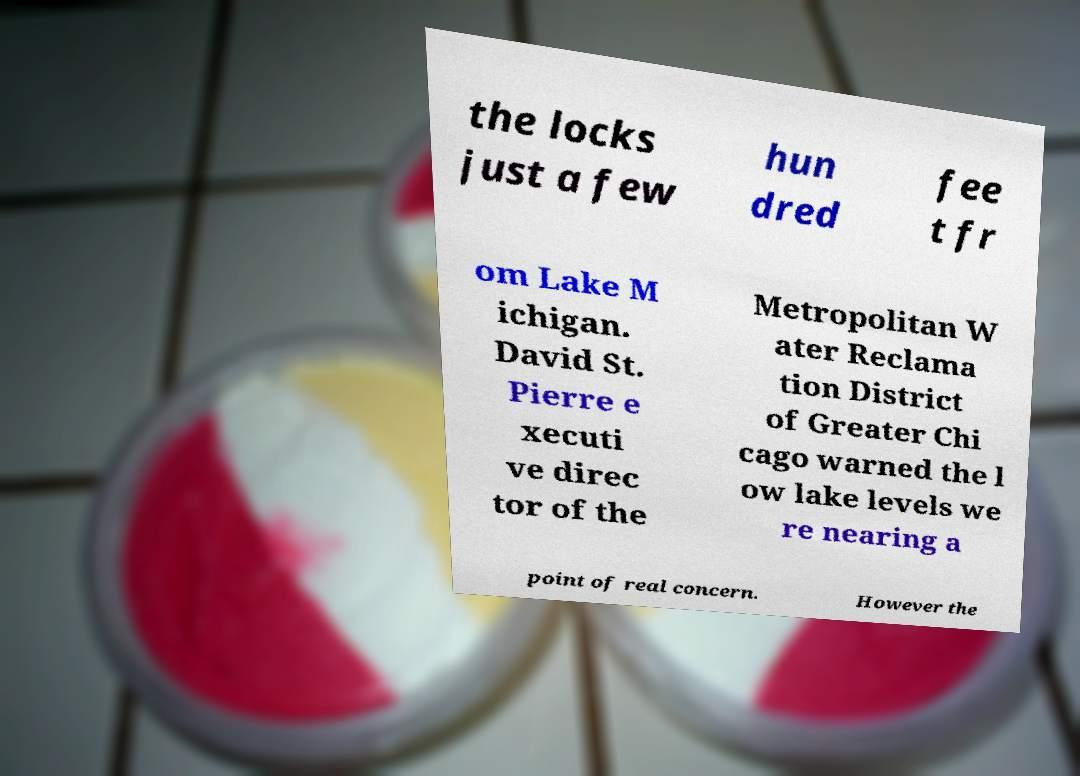Can you read and provide the text displayed in the image?This photo seems to have some interesting text. Can you extract and type it out for me? the locks just a few hun dred fee t fr om Lake M ichigan. David St. Pierre e xecuti ve direc tor of the Metropolitan W ater Reclama tion District of Greater Chi cago warned the l ow lake levels we re nearing a point of real concern. However the 